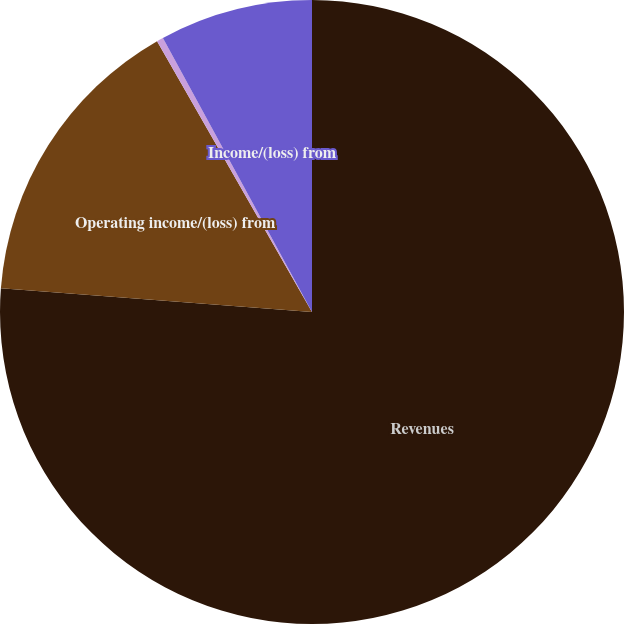<chart> <loc_0><loc_0><loc_500><loc_500><pie_chart><fcel>Revenues<fcel>Operating income/(loss) from<fcel>(Provision for)/benefit from<fcel>Income/(loss) from<nl><fcel>76.21%<fcel>15.52%<fcel>0.34%<fcel>7.93%<nl></chart> 